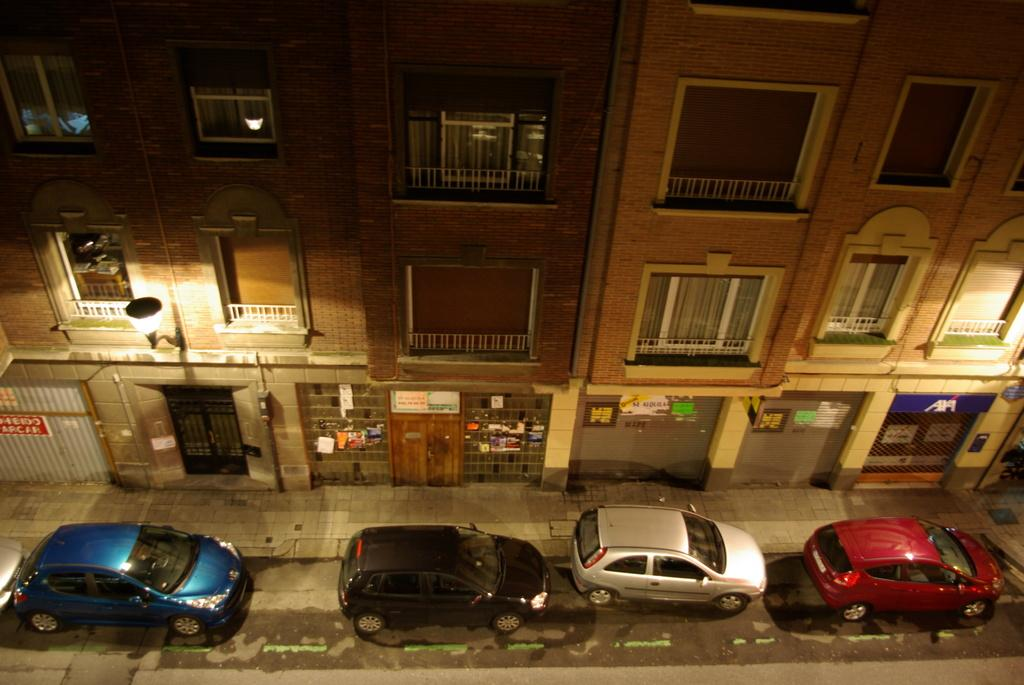What type of vehicles can be seen on the road in the image? There are cars on the road in the image. What structures are located near the cars? There are buildings beside the cars. What can be seen illuminating the scene in the image? There are lights visible in the image. Can you tell me how the tiger is providing comfort to the cars in the image? There is no tiger present in the image, so it cannot provide comfort to the cars. 